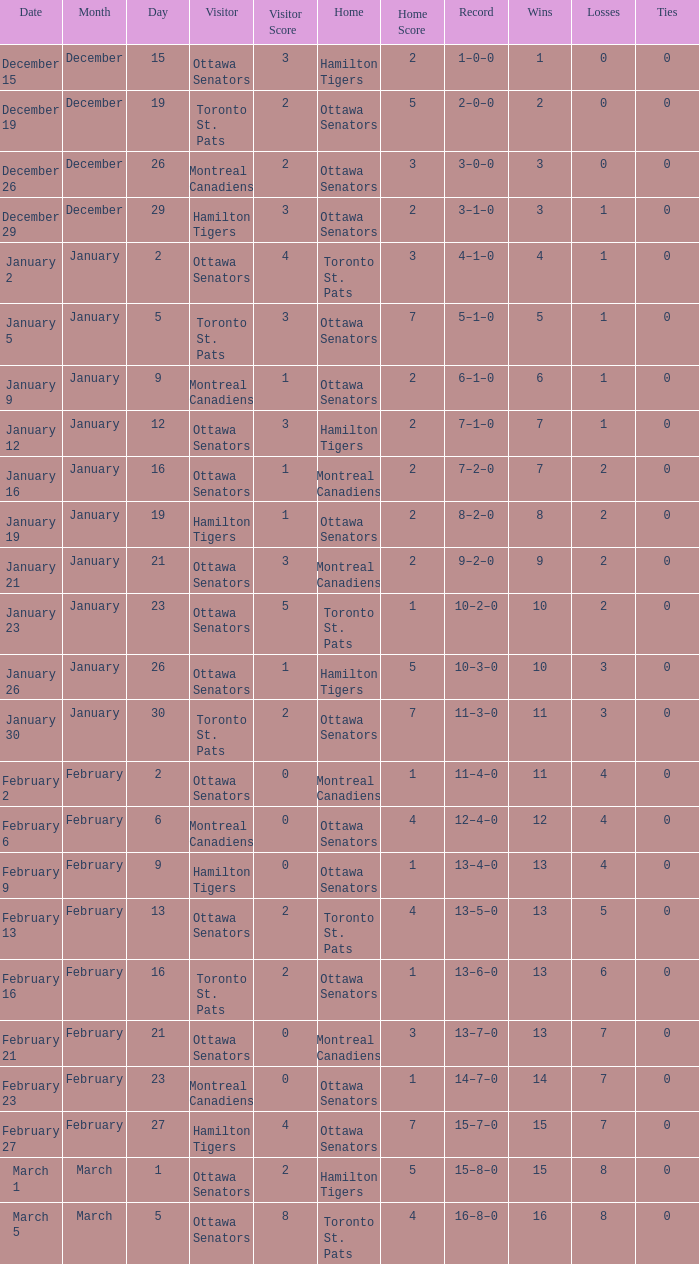In which game did the ottawa senators visit and the home team had a score of 1-5? Hamilton Tigers. Would you be able to parse every entry in this table? {'header': ['Date', 'Month', 'Day', 'Visitor', 'Visitor Score', 'Home', 'Home Score', 'Record', 'Wins', 'Losses', 'Ties'], 'rows': [['December 15', 'December', '15', 'Ottawa Senators', '3', 'Hamilton Tigers', '2', '1–0–0', '1', '0', '0'], ['December 19', 'December', '19', 'Toronto St. Pats', '2', 'Ottawa Senators', '5', '2–0–0', '2', '0', '0'], ['December 26', 'December', '26', 'Montreal Canadiens', '2', 'Ottawa Senators', '3', '3–0–0', '3', '0', '0'], ['December 29', 'December', '29', 'Hamilton Tigers', '3', 'Ottawa Senators', '2', '3–1–0', '3', '1', '0'], ['January 2', 'January', '2', 'Ottawa Senators', '4', 'Toronto St. Pats', '3', '4–1–0', '4', '1', '0'], ['January 5', 'January', '5', 'Toronto St. Pats', '3', 'Ottawa Senators', '7', '5–1–0', '5', '1', '0'], ['January 9', 'January', '9', 'Montreal Canadiens', '1', 'Ottawa Senators', '2', '6–1–0', '6', '1', '0'], ['January 12', 'January', '12', 'Ottawa Senators', '3', 'Hamilton Tigers', '2', '7–1–0', '7', '1', '0'], ['January 16', 'January', '16', 'Ottawa Senators', '1', 'Montreal Canadiens', '2', '7–2–0', '7', '2', '0'], ['January 19', 'January', '19', 'Hamilton Tigers', '1', 'Ottawa Senators', '2', '8–2–0', '8', '2', '0'], ['January 21', 'January', '21', 'Ottawa Senators', '3', 'Montreal Canadiens', '2', '9–2–0', '9', '2', '0'], ['January 23', 'January', '23', 'Ottawa Senators', '5', 'Toronto St. Pats', '1', '10–2–0', '10', '2', '0'], ['January 26', 'January', '26', 'Ottawa Senators', '1', 'Hamilton Tigers', '5', '10–3–0', '10', '3', '0'], ['January 30', 'January', '30', 'Toronto St. Pats', '2', 'Ottawa Senators', '7', '11–3–0', '11', '3', '0'], ['February 2', 'February', '2', 'Ottawa Senators', '0', 'Montreal Canadiens', '1', '11–4–0', '11', '4', '0'], ['February 6', 'February', '6', 'Montreal Canadiens', '0', 'Ottawa Senators', '4', '12–4–0', '12', '4', '0'], ['February 9', 'February', '9', 'Hamilton Tigers', '0', 'Ottawa Senators', '1', '13–4–0', '13', '4', '0'], ['February 13', 'February', '13', 'Ottawa Senators', '2', 'Toronto St. Pats', '4', '13–5–0', '13', '5', '0'], ['February 16', 'February', '16', 'Toronto St. Pats', '2', 'Ottawa Senators', '1', '13–6–0', '13', '6', '0'], ['February 21', 'February', '21', 'Ottawa Senators', '0', 'Montreal Canadiens', '3', '13–7–0', '13', '7', '0'], ['February 23', 'February', '23', 'Montreal Canadiens', '0', 'Ottawa Senators', '1', '14–7–0', '14', '7', '0'], ['February 27', 'February', '27', 'Hamilton Tigers', '4', 'Ottawa Senators', '7', '15–7–0', '15', '7', '0'], ['March 1', 'March', '1', 'Ottawa Senators', '2', 'Hamilton Tigers', '5', '15–8–0', '15', '8', '0'], ['March 5', 'March', '5', 'Ottawa Senators', '8', 'Toronto St. Pats', '4', '16–8–0', '16', '8', '0']]} 